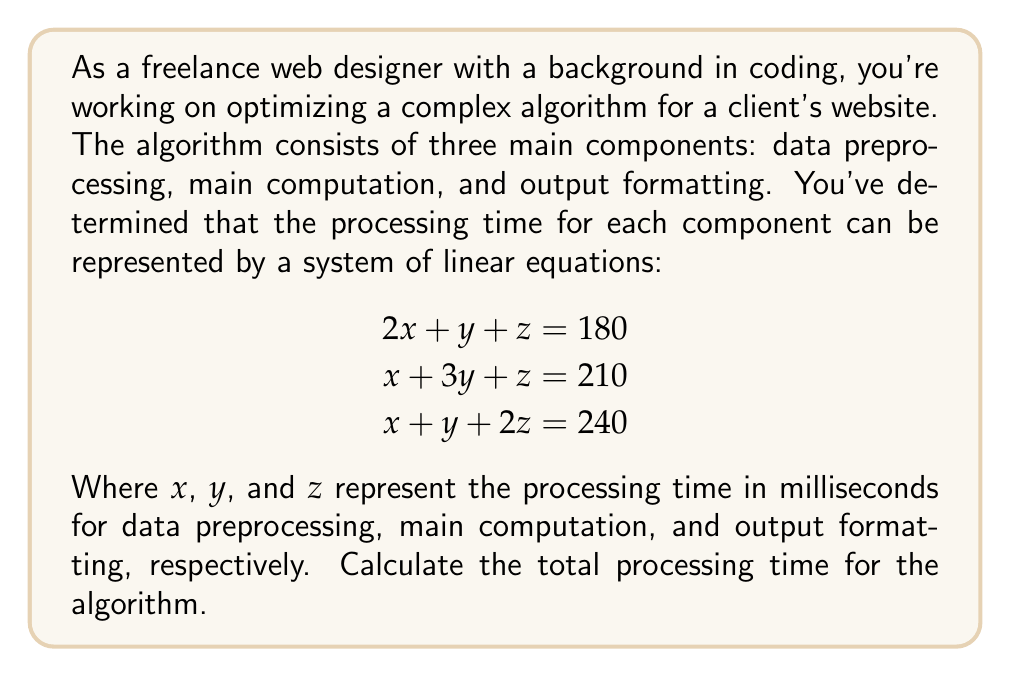Solve this math problem. To solve this problem, we need to use techniques from linear algebra to solve the system of equations and find the values of $x$, $y$, and $z$. Then, we'll sum these values to get the total processing time.

Step 1: Set up the augmented matrix
$$\begin{bmatrix}
2 & 1 & 1 & 180 \\
1 & 3 & 1 & 210 \\
1 & 1 & 2 & 240
\end{bmatrix}$$

Step 2: Use Gaussian elimination to solve the system
Row operations:
1. $R_2 \rightarrow R_2 - \frac{1}{2}R_1$
2. $R_3 \rightarrow R_3 - \frac{1}{2}R_1$

$$\begin{bmatrix}
2 & 1 & 1 & 180 \\
0 & \frac{5}{2} & \frac{1}{2} & 120 \\
0 & \frac{1}{2} & \frac{3}{2} & 150
\end{bmatrix}$$

3. $R_3 \rightarrow R_3 - \frac{1}{5}R_2$

$$\begin{bmatrix}
2 & 1 & 1 & 180 \\
0 & \frac{5}{2} & \frac{1}{2} & 120 \\
0 & 0 & \frac{7}{5} & 126
\end{bmatrix}$$

Step 3: Back-substitute to find $x$, $y$, and $z$

$z = \frac{126}{\frac{7}{5}} = 90$

$y = \frac{120 - \frac{1}{2}(90)}{2.5} = 30$

$x = \frac{180 - 30 - 90}{2} = 30$

Step 4: Calculate the total processing time
Total time = $x + y + z = 30 + 30 + 90 = 150$ milliseconds
Answer: 150 ms 